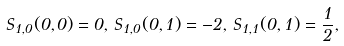<formula> <loc_0><loc_0><loc_500><loc_500>S _ { 1 , 0 } ( 0 , 0 ) = 0 , \, S _ { 1 , 0 } ( 0 , 1 ) = - 2 , \, S _ { 1 , 1 } ( 0 , 1 ) = \frac { 1 } { 2 } ,</formula> 